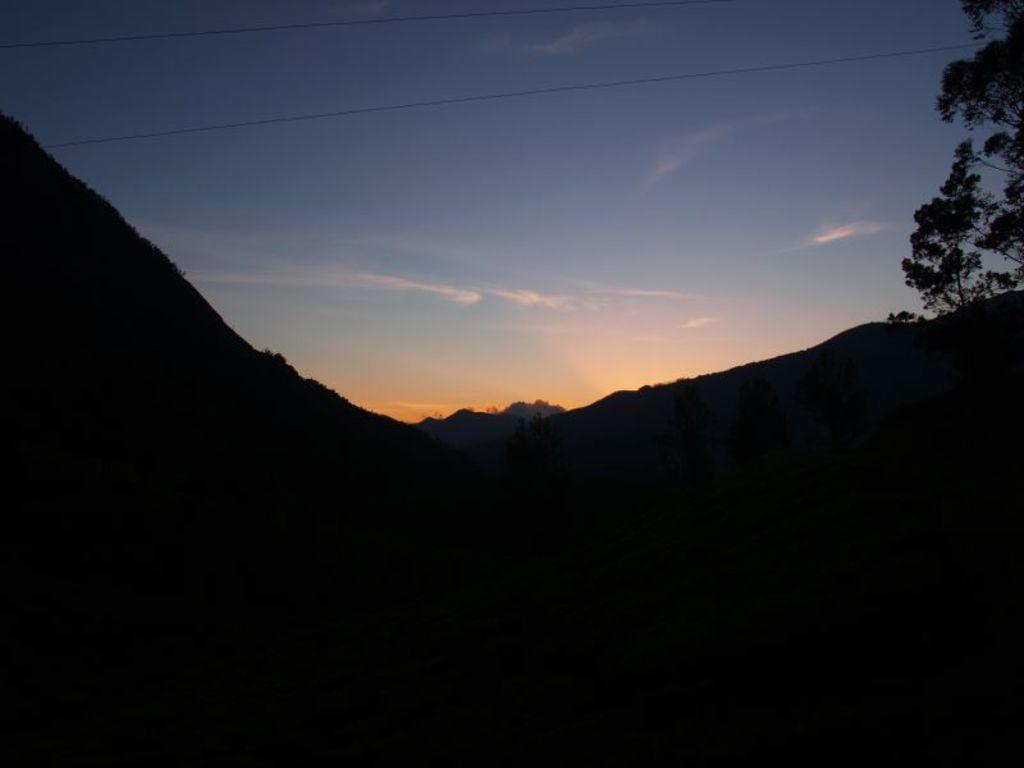What type of natural features can be seen at the bottom of the image? There are trees and plants on a mountain at the bottom of the image. What can be seen in the background of the image? There are clouds in the background of the image. What color is the sky in the image? The sky is blue in the image. What type of brush is used to paint the clouds in the image? There is no indication that the image is a painting, and therefore no brush is used to create the clouds. What is the level of interest in the trees and plants on the mountain? The level of interest in the trees and plants on the mountain cannot be determined from the image alone. 